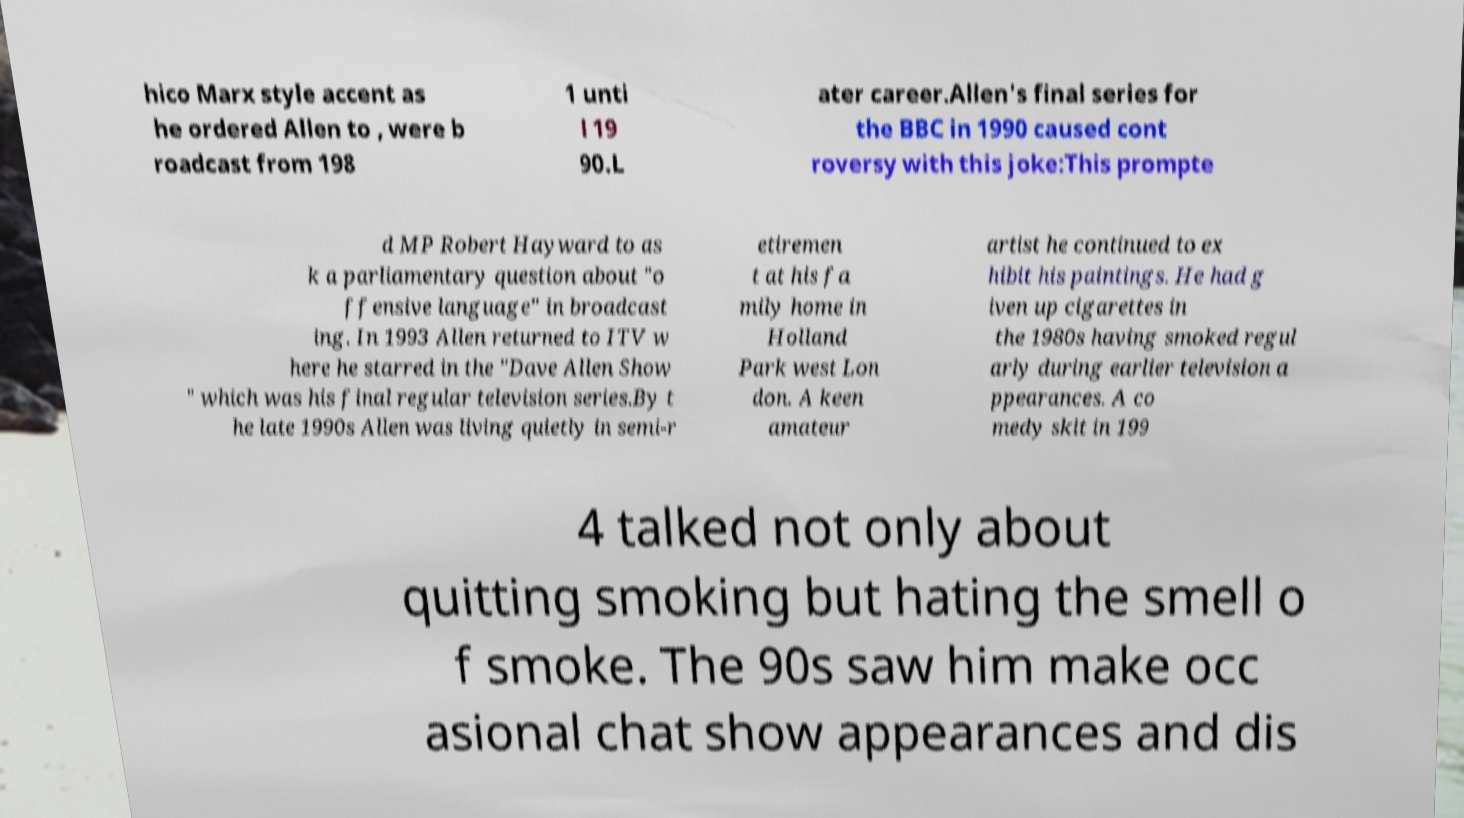Please read and relay the text visible in this image. What does it say? hico Marx style accent as he ordered Allen to , were b roadcast from 198 1 unti l 19 90.L ater career.Allen's final series for the BBC in 1990 caused cont roversy with this joke:This prompte d MP Robert Hayward to as k a parliamentary question about "o ffensive language" in broadcast ing. In 1993 Allen returned to ITV w here he starred in the "Dave Allen Show " which was his final regular television series.By t he late 1990s Allen was living quietly in semi-r etiremen t at his fa mily home in Holland Park west Lon don. A keen amateur artist he continued to ex hibit his paintings. He had g iven up cigarettes in the 1980s having smoked regul arly during earlier television a ppearances. A co medy skit in 199 4 talked not only about quitting smoking but hating the smell o f smoke. The 90s saw him make occ asional chat show appearances and dis 